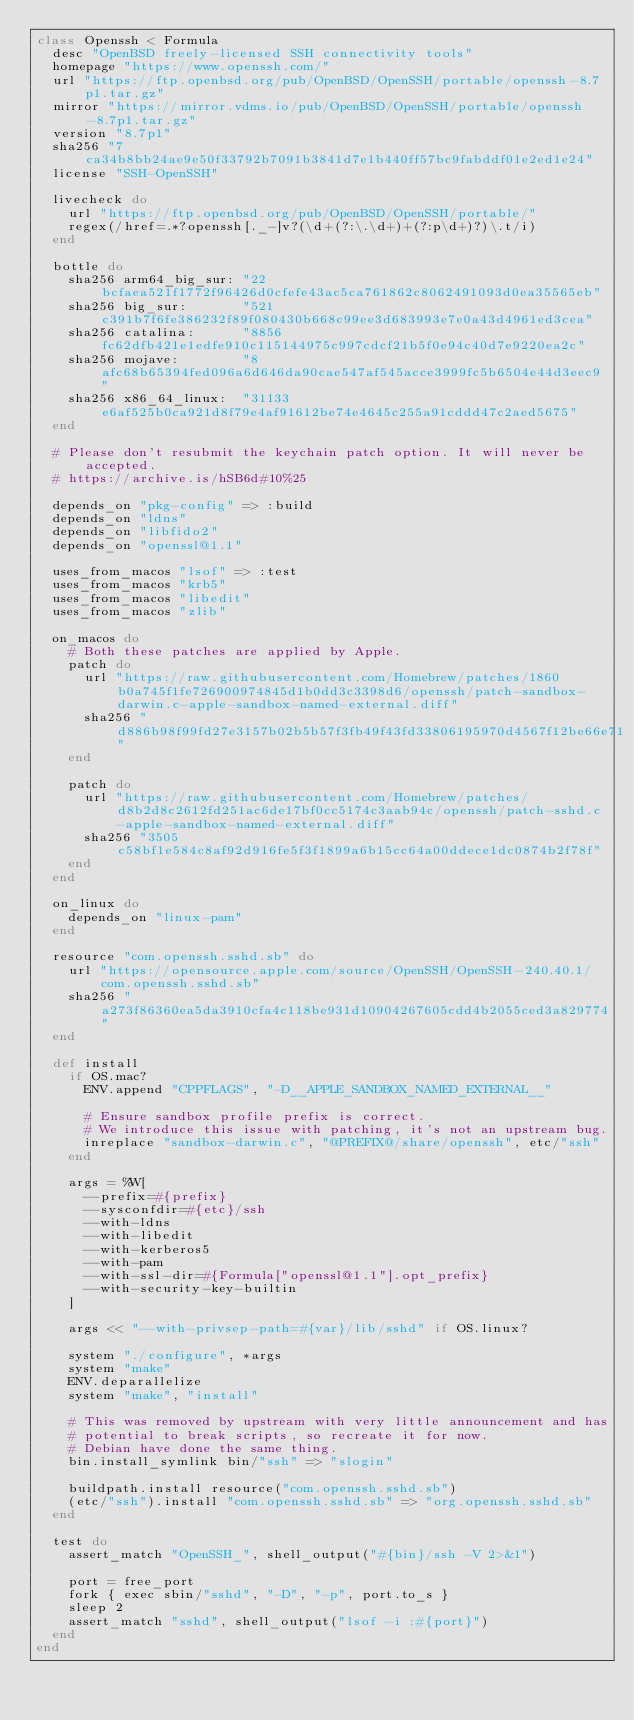Convert code to text. <code><loc_0><loc_0><loc_500><loc_500><_Ruby_>class Openssh < Formula
  desc "OpenBSD freely-licensed SSH connectivity tools"
  homepage "https://www.openssh.com/"
  url "https://ftp.openbsd.org/pub/OpenBSD/OpenSSH/portable/openssh-8.7p1.tar.gz"
  mirror "https://mirror.vdms.io/pub/OpenBSD/OpenSSH/portable/openssh-8.7p1.tar.gz"
  version "8.7p1"
  sha256 "7ca34b8bb24ae9e50f33792b7091b3841d7e1b440ff57bc9fabddf01e2ed1e24"
  license "SSH-OpenSSH"

  livecheck do
    url "https://ftp.openbsd.org/pub/OpenBSD/OpenSSH/portable/"
    regex(/href=.*?openssh[._-]v?(\d+(?:\.\d+)+(?:p\d+)?)\.t/i)
  end

  bottle do
    sha256 arm64_big_sur: "22bcfaea521f1772f96426d0cfefe43ac5ca761862c8062491093d0ea35565eb"
    sha256 big_sur:       "521c391b7f6fe386232f89f080430b668c99ee3d683993e7e0a43d4961ed3cea"
    sha256 catalina:      "8856fc62dfb421e1edfe910c115144975c997cdcf21b5f0e94c40d7e9220ea2c"
    sha256 mojave:        "8afc68b65394fed096a6d646da90cae547af545acce3999fc5b6504e44d3eec9"
    sha256 x86_64_linux:  "31133e6af525b0ca921d8f79e4af91612be74e4645c255a91cddd47c2aed5675"
  end

  # Please don't resubmit the keychain patch option. It will never be accepted.
  # https://archive.is/hSB6d#10%25

  depends_on "pkg-config" => :build
  depends_on "ldns"
  depends_on "libfido2"
  depends_on "openssl@1.1"

  uses_from_macos "lsof" => :test
  uses_from_macos "krb5"
  uses_from_macos "libedit"
  uses_from_macos "zlib"

  on_macos do
    # Both these patches are applied by Apple.
    patch do
      url "https://raw.githubusercontent.com/Homebrew/patches/1860b0a745f1fe726900974845d1b0dd3c3398d6/openssh/patch-sandbox-darwin.c-apple-sandbox-named-external.diff"
      sha256 "d886b98f99fd27e3157b02b5b57f3fb49f43fd33806195970d4567f12be66e71"
    end

    patch do
      url "https://raw.githubusercontent.com/Homebrew/patches/d8b2d8c2612fd251ac6de17bf0cc5174c3aab94c/openssh/patch-sshd.c-apple-sandbox-named-external.diff"
      sha256 "3505c58bf1e584c8af92d916fe5f3f1899a6b15cc64a00ddece1dc0874b2f78f"
    end
  end

  on_linux do
    depends_on "linux-pam"
  end

  resource "com.openssh.sshd.sb" do
    url "https://opensource.apple.com/source/OpenSSH/OpenSSH-240.40.1/com.openssh.sshd.sb"
    sha256 "a273f86360ea5da3910cfa4c118be931d10904267605cdd4b2055ced3a829774"
  end

  def install
    if OS.mac?
      ENV.append "CPPFLAGS", "-D__APPLE_SANDBOX_NAMED_EXTERNAL__"

      # Ensure sandbox profile prefix is correct.
      # We introduce this issue with patching, it's not an upstream bug.
      inreplace "sandbox-darwin.c", "@PREFIX@/share/openssh", etc/"ssh"
    end

    args = %W[
      --prefix=#{prefix}
      --sysconfdir=#{etc}/ssh
      --with-ldns
      --with-libedit
      --with-kerberos5
      --with-pam
      --with-ssl-dir=#{Formula["openssl@1.1"].opt_prefix}
      --with-security-key-builtin
    ]

    args << "--with-privsep-path=#{var}/lib/sshd" if OS.linux?

    system "./configure", *args
    system "make"
    ENV.deparallelize
    system "make", "install"

    # This was removed by upstream with very little announcement and has
    # potential to break scripts, so recreate it for now.
    # Debian have done the same thing.
    bin.install_symlink bin/"ssh" => "slogin"

    buildpath.install resource("com.openssh.sshd.sb")
    (etc/"ssh").install "com.openssh.sshd.sb" => "org.openssh.sshd.sb"
  end

  test do
    assert_match "OpenSSH_", shell_output("#{bin}/ssh -V 2>&1")

    port = free_port
    fork { exec sbin/"sshd", "-D", "-p", port.to_s }
    sleep 2
    assert_match "sshd", shell_output("lsof -i :#{port}")
  end
end
</code> 